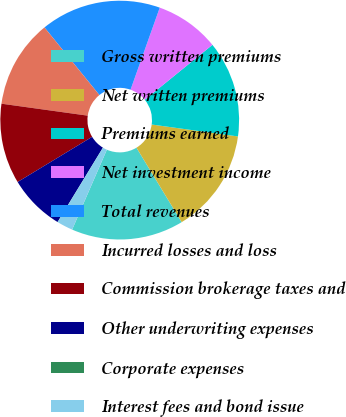Convert chart to OTSL. <chart><loc_0><loc_0><loc_500><loc_500><pie_chart><fcel>Gross written premiums<fcel>Net written premiums<fcel>Premiums earned<fcel>Net investment income<fcel>Total revenues<fcel>Incurred losses and loss<fcel>Commission brokerage taxes and<fcel>Other underwriting expenses<fcel>Corporate expenses<fcel>Interest fees and bond issue<nl><fcel>15.21%<fcel>14.13%<fcel>13.04%<fcel>8.7%<fcel>16.3%<fcel>11.95%<fcel>10.87%<fcel>7.61%<fcel>0.01%<fcel>2.18%<nl></chart> 